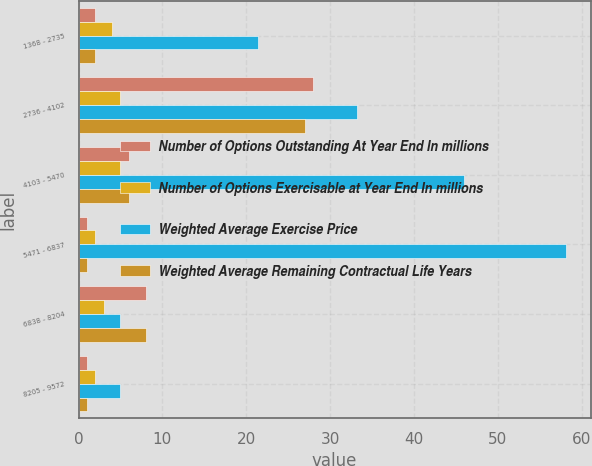<chart> <loc_0><loc_0><loc_500><loc_500><stacked_bar_chart><ecel><fcel>1368 - 2735<fcel>2736 - 4102<fcel>4103 - 5470<fcel>5471 - 6837<fcel>6838 - 8204<fcel>8205 - 9572<nl><fcel>Number of Options Outstanding At Year End In millions<fcel>2<fcel>28<fcel>6<fcel>1<fcel>8<fcel>1<nl><fcel>Number of Options Exercisable at Year End In millions<fcel>4<fcel>5<fcel>5<fcel>2<fcel>3<fcel>2<nl><fcel>Weighted Average Exercise Price<fcel>21.35<fcel>33.16<fcel>45.94<fcel>58.15<fcel>5<fcel>5<nl><fcel>Weighted Average Remaining Contractual Life Years<fcel>2<fcel>27<fcel>6<fcel>1<fcel>8<fcel>1<nl></chart> 